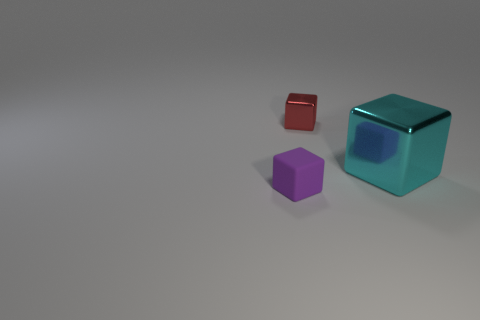What is the shape of the cyan object that is made of the same material as the red object?
Offer a very short reply. Cube. There is a red thing that is the same shape as the large cyan object; what is its material?
Provide a short and direct response. Metal. How many other objects are the same size as the purple matte object?
Offer a terse response. 1. What material is the cyan object?
Give a very brief answer. Metal. Is the number of shiny things in front of the red cube greater than the number of tiny purple cylinders?
Make the answer very short. Yes. What is the size of the object left of the thing behind the metallic block on the right side of the tiny red shiny thing?
Your answer should be compact. Small. What is the shape of the thing that is both on the left side of the big cyan shiny object and behind the purple matte block?
Your answer should be compact. Cube. Are there the same number of big shiny blocks that are left of the cyan metallic object and tiny cubes that are behind the small purple rubber object?
Provide a succinct answer. No. Are there any small red things that have the same material as the big block?
Your answer should be very brief. Yes. Is the material of the tiny object that is behind the big cyan metal cube the same as the cyan thing?
Your answer should be very brief. Yes. 